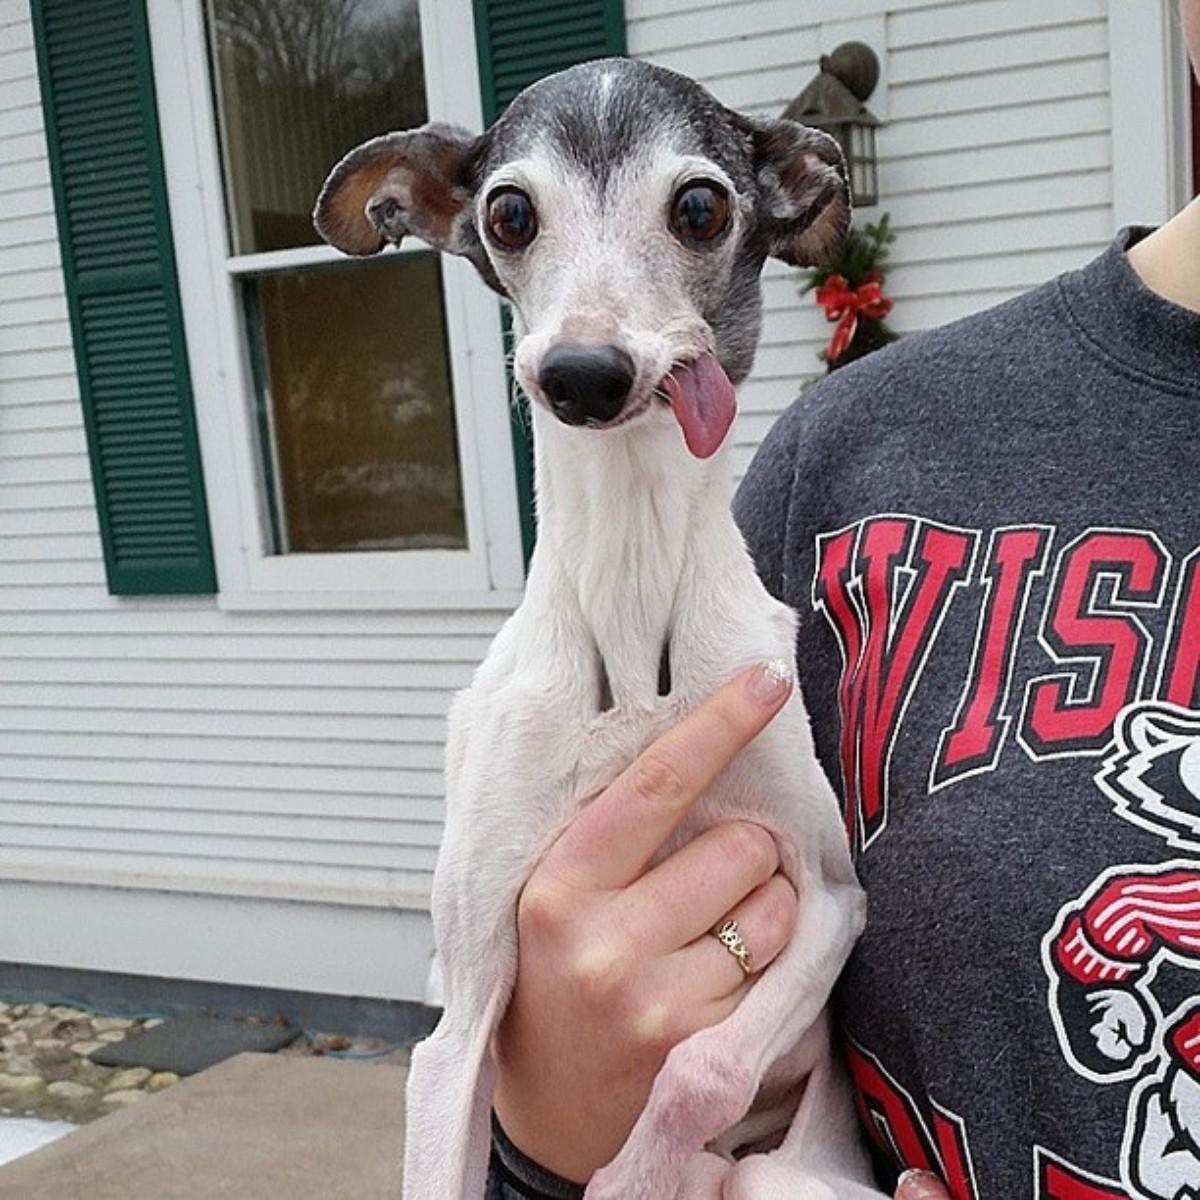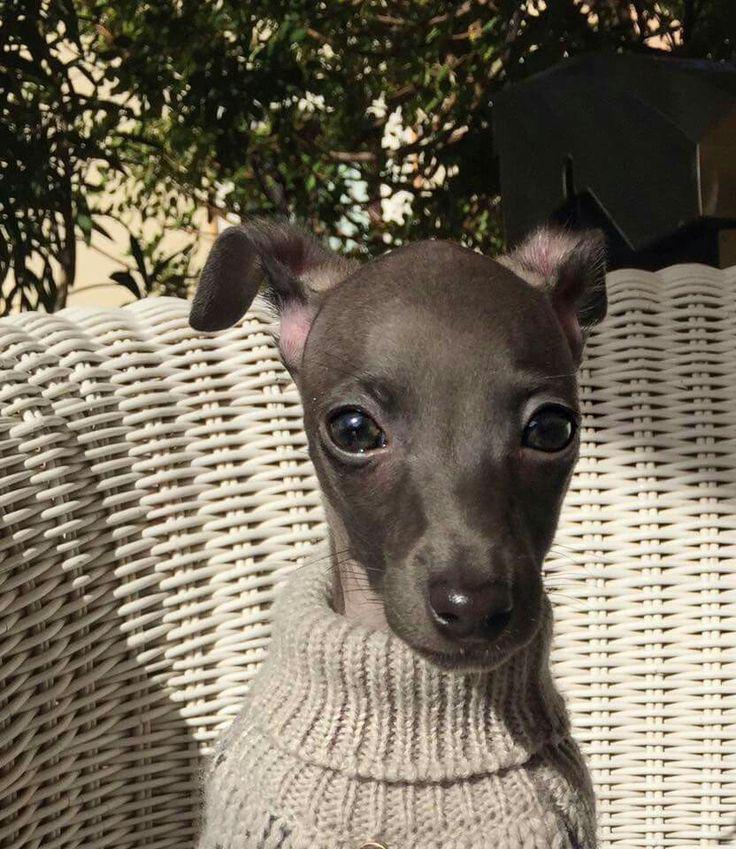The first image is the image on the left, the second image is the image on the right. Examine the images to the left and right. Is the description "An image shows a human limb touching a hound with its tongue hanging to the right." accurate? Answer yes or no. Yes. The first image is the image on the left, the second image is the image on the right. Examine the images to the left and right. Is the description "A dog is lying on the floor with its head up in the left image." accurate? Answer yes or no. No. 